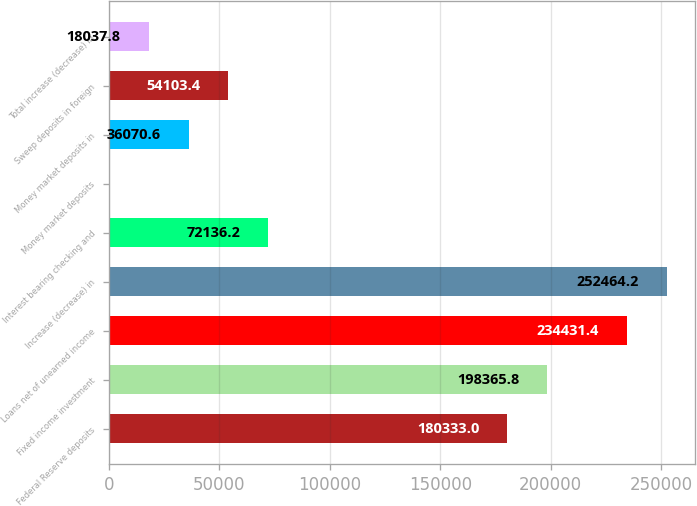Convert chart. <chart><loc_0><loc_0><loc_500><loc_500><bar_chart><fcel>Federal Reserve deposits<fcel>Fixed income investment<fcel>Loans net of unearned income<fcel>Increase (decrease) in<fcel>Interest bearing checking and<fcel>Money market deposits<fcel>Money market deposits in<fcel>Sweep deposits in foreign<fcel>Total increase (decrease) in<nl><fcel>180333<fcel>198366<fcel>234431<fcel>252464<fcel>72136.2<fcel>5<fcel>36070.6<fcel>54103.4<fcel>18037.8<nl></chart> 